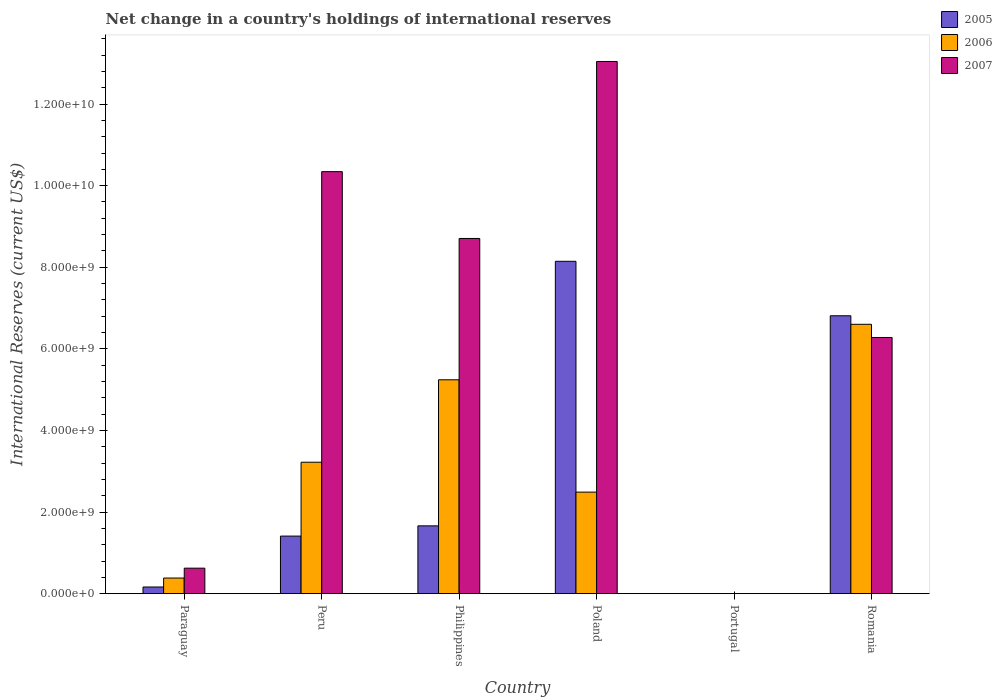Are the number of bars per tick equal to the number of legend labels?
Give a very brief answer. No. How many bars are there on the 1st tick from the left?
Your answer should be very brief. 3. What is the label of the 1st group of bars from the left?
Make the answer very short. Paraguay. In how many cases, is the number of bars for a given country not equal to the number of legend labels?
Provide a short and direct response. 1. What is the international reserves in 2007 in Philippines?
Keep it short and to the point. 8.71e+09. Across all countries, what is the maximum international reserves in 2007?
Your answer should be very brief. 1.30e+1. Across all countries, what is the minimum international reserves in 2005?
Offer a very short reply. 0. What is the total international reserves in 2006 in the graph?
Give a very brief answer. 1.79e+1. What is the difference between the international reserves in 2007 in Paraguay and that in Romania?
Your answer should be very brief. -5.65e+09. What is the difference between the international reserves in 2006 in Philippines and the international reserves in 2005 in Paraguay?
Offer a terse response. 5.08e+09. What is the average international reserves in 2005 per country?
Give a very brief answer. 3.03e+09. What is the difference between the international reserves of/in 2007 and international reserves of/in 2006 in Poland?
Ensure brevity in your answer.  1.06e+1. In how many countries, is the international reserves in 2007 greater than 4800000000 US$?
Your response must be concise. 4. What is the ratio of the international reserves in 2007 in Paraguay to that in Poland?
Offer a very short reply. 0.05. Is the international reserves in 2005 in Paraguay less than that in Romania?
Keep it short and to the point. Yes. What is the difference between the highest and the second highest international reserves in 2007?
Offer a very short reply. 4.34e+09. What is the difference between the highest and the lowest international reserves in 2006?
Keep it short and to the point. 6.60e+09. In how many countries, is the international reserves in 2006 greater than the average international reserves in 2006 taken over all countries?
Ensure brevity in your answer.  3. Is the sum of the international reserves in 2007 in Peru and Poland greater than the maximum international reserves in 2006 across all countries?
Your answer should be very brief. Yes. Is it the case that in every country, the sum of the international reserves in 2007 and international reserves in 2006 is greater than the international reserves in 2005?
Provide a succinct answer. No. Are all the bars in the graph horizontal?
Give a very brief answer. No. What is the difference between two consecutive major ticks on the Y-axis?
Provide a short and direct response. 2.00e+09. Are the values on the major ticks of Y-axis written in scientific E-notation?
Make the answer very short. Yes. Does the graph contain grids?
Keep it short and to the point. No. How many legend labels are there?
Ensure brevity in your answer.  3. What is the title of the graph?
Your response must be concise. Net change in a country's holdings of international reserves. Does "1968" appear as one of the legend labels in the graph?
Your answer should be very brief. No. What is the label or title of the X-axis?
Keep it short and to the point. Country. What is the label or title of the Y-axis?
Your answer should be very brief. International Reserves (current US$). What is the International Reserves (current US$) of 2005 in Paraguay?
Your answer should be compact. 1.63e+08. What is the International Reserves (current US$) in 2006 in Paraguay?
Give a very brief answer. 3.83e+08. What is the International Reserves (current US$) of 2007 in Paraguay?
Provide a short and direct response. 6.25e+08. What is the International Reserves (current US$) of 2005 in Peru?
Provide a short and direct response. 1.41e+09. What is the International Reserves (current US$) of 2006 in Peru?
Make the answer very short. 3.22e+09. What is the International Reserves (current US$) in 2007 in Peru?
Offer a very short reply. 1.03e+1. What is the International Reserves (current US$) of 2005 in Philippines?
Ensure brevity in your answer.  1.66e+09. What is the International Reserves (current US$) of 2006 in Philippines?
Provide a succinct answer. 5.24e+09. What is the International Reserves (current US$) in 2007 in Philippines?
Ensure brevity in your answer.  8.71e+09. What is the International Reserves (current US$) of 2005 in Poland?
Offer a very short reply. 8.15e+09. What is the International Reserves (current US$) in 2006 in Poland?
Your answer should be compact. 2.49e+09. What is the International Reserves (current US$) in 2007 in Poland?
Keep it short and to the point. 1.30e+1. What is the International Reserves (current US$) of 2005 in Portugal?
Provide a succinct answer. 0. What is the International Reserves (current US$) in 2005 in Romania?
Keep it short and to the point. 6.81e+09. What is the International Reserves (current US$) of 2006 in Romania?
Your response must be concise. 6.60e+09. What is the International Reserves (current US$) of 2007 in Romania?
Provide a succinct answer. 6.28e+09. Across all countries, what is the maximum International Reserves (current US$) of 2005?
Offer a very short reply. 8.15e+09. Across all countries, what is the maximum International Reserves (current US$) of 2006?
Provide a short and direct response. 6.60e+09. Across all countries, what is the maximum International Reserves (current US$) of 2007?
Offer a very short reply. 1.30e+1. Across all countries, what is the minimum International Reserves (current US$) of 2007?
Ensure brevity in your answer.  0. What is the total International Reserves (current US$) in 2005 in the graph?
Ensure brevity in your answer.  1.82e+1. What is the total International Reserves (current US$) of 2006 in the graph?
Provide a short and direct response. 1.79e+1. What is the total International Reserves (current US$) in 2007 in the graph?
Make the answer very short. 3.90e+1. What is the difference between the International Reserves (current US$) of 2005 in Paraguay and that in Peru?
Give a very brief answer. -1.25e+09. What is the difference between the International Reserves (current US$) in 2006 in Paraguay and that in Peru?
Offer a terse response. -2.84e+09. What is the difference between the International Reserves (current US$) in 2007 in Paraguay and that in Peru?
Make the answer very short. -9.72e+09. What is the difference between the International Reserves (current US$) of 2005 in Paraguay and that in Philippines?
Ensure brevity in your answer.  -1.50e+09. What is the difference between the International Reserves (current US$) in 2006 in Paraguay and that in Philippines?
Keep it short and to the point. -4.86e+09. What is the difference between the International Reserves (current US$) in 2007 in Paraguay and that in Philippines?
Provide a short and direct response. -8.08e+09. What is the difference between the International Reserves (current US$) of 2005 in Paraguay and that in Poland?
Provide a short and direct response. -7.98e+09. What is the difference between the International Reserves (current US$) in 2006 in Paraguay and that in Poland?
Ensure brevity in your answer.  -2.11e+09. What is the difference between the International Reserves (current US$) in 2007 in Paraguay and that in Poland?
Offer a very short reply. -1.24e+1. What is the difference between the International Reserves (current US$) of 2005 in Paraguay and that in Romania?
Your response must be concise. -6.65e+09. What is the difference between the International Reserves (current US$) in 2006 in Paraguay and that in Romania?
Your response must be concise. -6.22e+09. What is the difference between the International Reserves (current US$) in 2007 in Paraguay and that in Romania?
Keep it short and to the point. -5.65e+09. What is the difference between the International Reserves (current US$) of 2005 in Peru and that in Philippines?
Offer a terse response. -2.51e+08. What is the difference between the International Reserves (current US$) in 2006 in Peru and that in Philippines?
Provide a succinct answer. -2.02e+09. What is the difference between the International Reserves (current US$) of 2007 in Peru and that in Philippines?
Give a very brief answer. 1.64e+09. What is the difference between the International Reserves (current US$) of 2005 in Peru and that in Poland?
Provide a short and direct response. -6.73e+09. What is the difference between the International Reserves (current US$) in 2006 in Peru and that in Poland?
Your answer should be very brief. 7.33e+08. What is the difference between the International Reserves (current US$) in 2007 in Peru and that in Poland?
Your answer should be very brief. -2.70e+09. What is the difference between the International Reserves (current US$) in 2005 in Peru and that in Romania?
Give a very brief answer. -5.40e+09. What is the difference between the International Reserves (current US$) in 2006 in Peru and that in Romania?
Your response must be concise. -3.38e+09. What is the difference between the International Reserves (current US$) in 2007 in Peru and that in Romania?
Your answer should be very brief. 4.06e+09. What is the difference between the International Reserves (current US$) in 2005 in Philippines and that in Poland?
Provide a succinct answer. -6.48e+09. What is the difference between the International Reserves (current US$) of 2006 in Philippines and that in Poland?
Keep it short and to the point. 2.75e+09. What is the difference between the International Reserves (current US$) in 2007 in Philippines and that in Poland?
Your answer should be compact. -4.34e+09. What is the difference between the International Reserves (current US$) of 2005 in Philippines and that in Romania?
Make the answer very short. -5.15e+09. What is the difference between the International Reserves (current US$) of 2006 in Philippines and that in Romania?
Provide a short and direct response. -1.36e+09. What is the difference between the International Reserves (current US$) in 2007 in Philippines and that in Romania?
Your response must be concise. 2.43e+09. What is the difference between the International Reserves (current US$) of 2005 in Poland and that in Romania?
Provide a succinct answer. 1.34e+09. What is the difference between the International Reserves (current US$) of 2006 in Poland and that in Romania?
Offer a terse response. -4.11e+09. What is the difference between the International Reserves (current US$) in 2007 in Poland and that in Romania?
Give a very brief answer. 6.76e+09. What is the difference between the International Reserves (current US$) of 2005 in Paraguay and the International Reserves (current US$) of 2006 in Peru?
Your answer should be very brief. -3.06e+09. What is the difference between the International Reserves (current US$) of 2005 in Paraguay and the International Reserves (current US$) of 2007 in Peru?
Make the answer very short. -1.02e+1. What is the difference between the International Reserves (current US$) in 2006 in Paraguay and the International Reserves (current US$) in 2007 in Peru?
Keep it short and to the point. -9.96e+09. What is the difference between the International Reserves (current US$) of 2005 in Paraguay and the International Reserves (current US$) of 2006 in Philippines?
Your response must be concise. -5.08e+09. What is the difference between the International Reserves (current US$) of 2005 in Paraguay and the International Reserves (current US$) of 2007 in Philippines?
Your response must be concise. -8.54e+09. What is the difference between the International Reserves (current US$) in 2006 in Paraguay and the International Reserves (current US$) in 2007 in Philippines?
Give a very brief answer. -8.32e+09. What is the difference between the International Reserves (current US$) of 2005 in Paraguay and the International Reserves (current US$) of 2006 in Poland?
Ensure brevity in your answer.  -2.33e+09. What is the difference between the International Reserves (current US$) of 2005 in Paraguay and the International Reserves (current US$) of 2007 in Poland?
Keep it short and to the point. -1.29e+1. What is the difference between the International Reserves (current US$) in 2006 in Paraguay and the International Reserves (current US$) in 2007 in Poland?
Offer a terse response. -1.27e+1. What is the difference between the International Reserves (current US$) of 2005 in Paraguay and the International Reserves (current US$) of 2006 in Romania?
Keep it short and to the point. -6.44e+09. What is the difference between the International Reserves (current US$) in 2005 in Paraguay and the International Reserves (current US$) in 2007 in Romania?
Give a very brief answer. -6.12e+09. What is the difference between the International Reserves (current US$) of 2006 in Paraguay and the International Reserves (current US$) of 2007 in Romania?
Your answer should be very brief. -5.90e+09. What is the difference between the International Reserves (current US$) in 2005 in Peru and the International Reserves (current US$) in 2006 in Philippines?
Provide a succinct answer. -3.83e+09. What is the difference between the International Reserves (current US$) of 2005 in Peru and the International Reserves (current US$) of 2007 in Philippines?
Provide a succinct answer. -7.29e+09. What is the difference between the International Reserves (current US$) in 2006 in Peru and the International Reserves (current US$) in 2007 in Philippines?
Keep it short and to the point. -5.48e+09. What is the difference between the International Reserves (current US$) in 2005 in Peru and the International Reserves (current US$) in 2006 in Poland?
Offer a terse response. -1.08e+09. What is the difference between the International Reserves (current US$) of 2005 in Peru and the International Reserves (current US$) of 2007 in Poland?
Offer a terse response. -1.16e+1. What is the difference between the International Reserves (current US$) in 2006 in Peru and the International Reserves (current US$) in 2007 in Poland?
Offer a terse response. -9.82e+09. What is the difference between the International Reserves (current US$) in 2005 in Peru and the International Reserves (current US$) in 2006 in Romania?
Your answer should be very brief. -5.19e+09. What is the difference between the International Reserves (current US$) of 2005 in Peru and the International Reserves (current US$) of 2007 in Romania?
Your answer should be very brief. -4.87e+09. What is the difference between the International Reserves (current US$) of 2006 in Peru and the International Reserves (current US$) of 2007 in Romania?
Keep it short and to the point. -3.06e+09. What is the difference between the International Reserves (current US$) in 2005 in Philippines and the International Reserves (current US$) in 2006 in Poland?
Offer a terse response. -8.27e+08. What is the difference between the International Reserves (current US$) in 2005 in Philippines and the International Reserves (current US$) in 2007 in Poland?
Provide a short and direct response. -1.14e+1. What is the difference between the International Reserves (current US$) in 2006 in Philippines and the International Reserves (current US$) in 2007 in Poland?
Your answer should be very brief. -7.80e+09. What is the difference between the International Reserves (current US$) in 2005 in Philippines and the International Reserves (current US$) in 2006 in Romania?
Your response must be concise. -4.94e+09. What is the difference between the International Reserves (current US$) of 2005 in Philippines and the International Reserves (current US$) of 2007 in Romania?
Offer a terse response. -4.62e+09. What is the difference between the International Reserves (current US$) of 2006 in Philippines and the International Reserves (current US$) of 2007 in Romania?
Your answer should be compact. -1.04e+09. What is the difference between the International Reserves (current US$) of 2005 in Poland and the International Reserves (current US$) of 2006 in Romania?
Your answer should be compact. 1.54e+09. What is the difference between the International Reserves (current US$) of 2005 in Poland and the International Reserves (current US$) of 2007 in Romania?
Your answer should be very brief. 1.87e+09. What is the difference between the International Reserves (current US$) of 2006 in Poland and the International Reserves (current US$) of 2007 in Romania?
Your answer should be compact. -3.79e+09. What is the average International Reserves (current US$) in 2005 per country?
Your response must be concise. 3.03e+09. What is the average International Reserves (current US$) of 2006 per country?
Provide a succinct answer. 2.99e+09. What is the average International Reserves (current US$) of 2007 per country?
Your answer should be very brief. 6.50e+09. What is the difference between the International Reserves (current US$) of 2005 and International Reserves (current US$) of 2006 in Paraguay?
Keep it short and to the point. -2.20e+08. What is the difference between the International Reserves (current US$) of 2005 and International Reserves (current US$) of 2007 in Paraguay?
Your response must be concise. -4.62e+08. What is the difference between the International Reserves (current US$) in 2006 and International Reserves (current US$) in 2007 in Paraguay?
Ensure brevity in your answer.  -2.42e+08. What is the difference between the International Reserves (current US$) in 2005 and International Reserves (current US$) in 2006 in Peru?
Keep it short and to the point. -1.81e+09. What is the difference between the International Reserves (current US$) of 2005 and International Reserves (current US$) of 2007 in Peru?
Ensure brevity in your answer.  -8.93e+09. What is the difference between the International Reserves (current US$) in 2006 and International Reserves (current US$) in 2007 in Peru?
Provide a short and direct response. -7.12e+09. What is the difference between the International Reserves (current US$) in 2005 and International Reserves (current US$) in 2006 in Philippines?
Give a very brief answer. -3.58e+09. What is the difference between the International Reserves (current US$) of 2005 and International Reserves (current US$) of 2007 in Philippines?
Provide a short and direct response. -7.04e+09. What is the difference between the International Reserves (current US$) in 2006 and International Reserves (current US$) in 2007 in Philippines?
Ensure brevity in your answer.  -3.46e+09. What is the difference between the International Reserves (current US$) of 2005 and International Reserves (current US$) of 2006 in Poland?
Your response must be concise. 5.66e+09. What is the difference between the International Reserves (current US$) in 2005 and International Reserves (current US$) in 2007 in Poland?
Offer a very short reply. -4.90e+09. What is the difference between the International Reserves (current US$) of 2006 and International Reserves (current US$) of 2007 in Poland?
Provide a short and direct response. -1.06e+1. What is the difference between the International Reserves (current US$) of 2005 and International Reserves (current US$) of 2006 in Romania?
Provide a succinct answer. 2.09e+08. What is the difference between the International Reserves (current US$) in 2005 and International Reserves (current US$) in 2007 in Romania?
Give a very brief answer. 5.32e+08. What is the difference between the International Reserves (current US$) of 2006 and International Reserves (current US$) of 2007 in Romania?
Give a very brief answer. 3.23e+08. What is the ratio of the International Reserves (current US$) of 2005 in Paraguay to that in Peru?
Your answer should be compact. 0.12. What is the ratio of the International Reserves (current US$) in 2006 in Paraguay to that in Peru?
Offer a very short reply. 0.12. What is the ratio of the International Reserves (current US$) of 2007 in Paraguay to that in Peru?
Ensure brevity in your answer.  0.06. What is the ratio of the International Reserves (current US$) of 2005 in Paraguay to that in Philippines?
Your answer should be compact. 0.1. What is the ratio of the International Reserves (current US$) in 2006 in Paraguay to that in Philippines?
Your answer should be compact. 0.07. What is the ratio of the International Reserves (current US$) of 2007 in Paraguay to that in Philippines?
Ensure brevity in your answer.  0.07. What is the ratio of the International Reserves (current US$) in 2006 in Paraguay to that in Poland?
Ensure brevity in your answer.  0.15. What is the ratio of the International Reserves (current US$) in 2007 in Paraguay to that in Poland?
Your response must be concise. 0.05. What is the ratio of the International Reserves (current US$) of 2005 in Paraguay to that in Romania?
Offer a very short reply. 0.02. What is the ratio of the International Reserves (current US$) of 2006 in Paraguay to that in Romania?
Your answer should be very brief. 0.06. What is the ratio of the International Reserves (current US$) of 2007 in Paraguay to that in Romania?
Offer a very short reply. 0.1. What is the ratio of the International Reserves (current US$) in 2005 in Peru to that in Philippines?
Your response must be concise. 0.85. What is the ratio of the International Reserves (current US$) in 2006 in Peru to that in Philippines?
Offer a very short reply. 0.61. What is the ratio of the International Reserves (current US$) in 2007 in Peru to that in Philippines?
Give a very brief answer. 1.19. What is the ratio of the International Reserves (current US$) in 2005 in Peru to that in Poland?
Keep it short and to the point. 0.17. What is the ratio of the International Reserves (current US$) of 2006 in Peru to that in Poland?
Provide a short and direct response. 1.29. What is the ratio of the International Reserves (current US$) in 2007 in Peru to that in Poland?
Give a very brief answer. 0.79. What is the ratio of the International Reserves (current US$) of 2005 in Peru to that in Romania?
Provide a short and direct response. 0.21. What is the ratio of the International Reserves (current US$) of 2006 in Peru to that in Romania?
Provide a succinct answer. 0.49. What is the ratio of the International Reserves (current US$) of 2007 in Peru to that in Romania?
Provide a succinct answer. 1.65. What is the ratio of the International Reserves (current US$) in 2005 in Philippines to that in Poland?
Provide a succinct answer. 0.2. What is the ratio of the International Reserves (current US$) of 2006 in Philippines to that in Poland?
Offer a terse response. 2.11. What is the ratio of the International Reserves (current US$) in 2007 in Philippines to that in Poland?
Offer a very short reply. 0.67. What is the ratio of the International Reserves (current US$) in 2005 in Philippines to that in Romania?
Ensure brevity in your answer.  0.24. What is the ratio of the International Reserves (current US$) in 2006 in Philippines to that in Romania?
Ensure brevity in your answer.  0.79. What is the ratio of the International Reserves (current US$) in 2007 in Philippines to that in Romania?
Your response must be concise. 1.39. What is the ratio of the International Reserves (current US$) of 2005 in Poland to that in Romania?
Make the answer very short. 1.2. What is the ratio of the International Reserves (current US$) of 2006 in Poland to that in Romania?
Your response must be concise. 0.38. What is the ratio of the International Reserves (current US$) of 2007 in Poland to that in Romania?
Ensure brevity in your answer.  2.08. What is the difference between the highest and the second highest International Reserves (current US$) in 2005?
Give a very brief answer. 1.34e+09. What is the difference between the highest and the second highest International Reserves (current US$) in 2006?
Give a very brief answer. 1.36e+09. What is the difference between the highest and the second highest International Reserves (current US$) of 2007?
Make the answer very short. 2.70e+09. What is the difference between the highest and the lowest International Reserves (current US$) of 2005?
Offer a terse response. 8.15e+09. What is the difference between the highest and the lowest International Reserves (current US$) of 2006?
Provide a succinct answer. 6.60e+09. What is the difference between the highest and the lowest International Reserves (current US$) of 2007?
Give a very brief answer. 1.30e+1. 